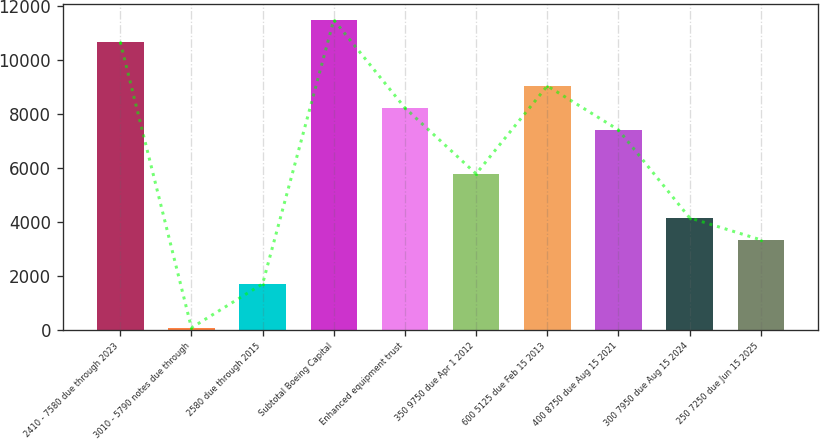<chart> <loc_0><loc_0><loc_500><loc_500><bar_chart><fcel>2410 - 7580 due through 2023<fcel>3010 - 5790 notes due through<fcel>2580 due through 2015<fcel>Subtotal Boeing Capital<fcel>Enhanced equipment trust<fcel>350 9750 due Apr 1 2012<fcel>600 5125 due Feb 15 2013<fcel>400 8750 due Aug 15 2021<fcel>300 7950 due Aug 15 2024<fcel>250 7250 due Jun 15 2025<nl><fcel>10660.8<fcel>71<fcel>1700.2<fcel>11475.4<fcel>8217<fcel>5773.2<fcel>9031.6<fcel>7402.4<fcel>4144<fcel>3329.4<nl></chart> 